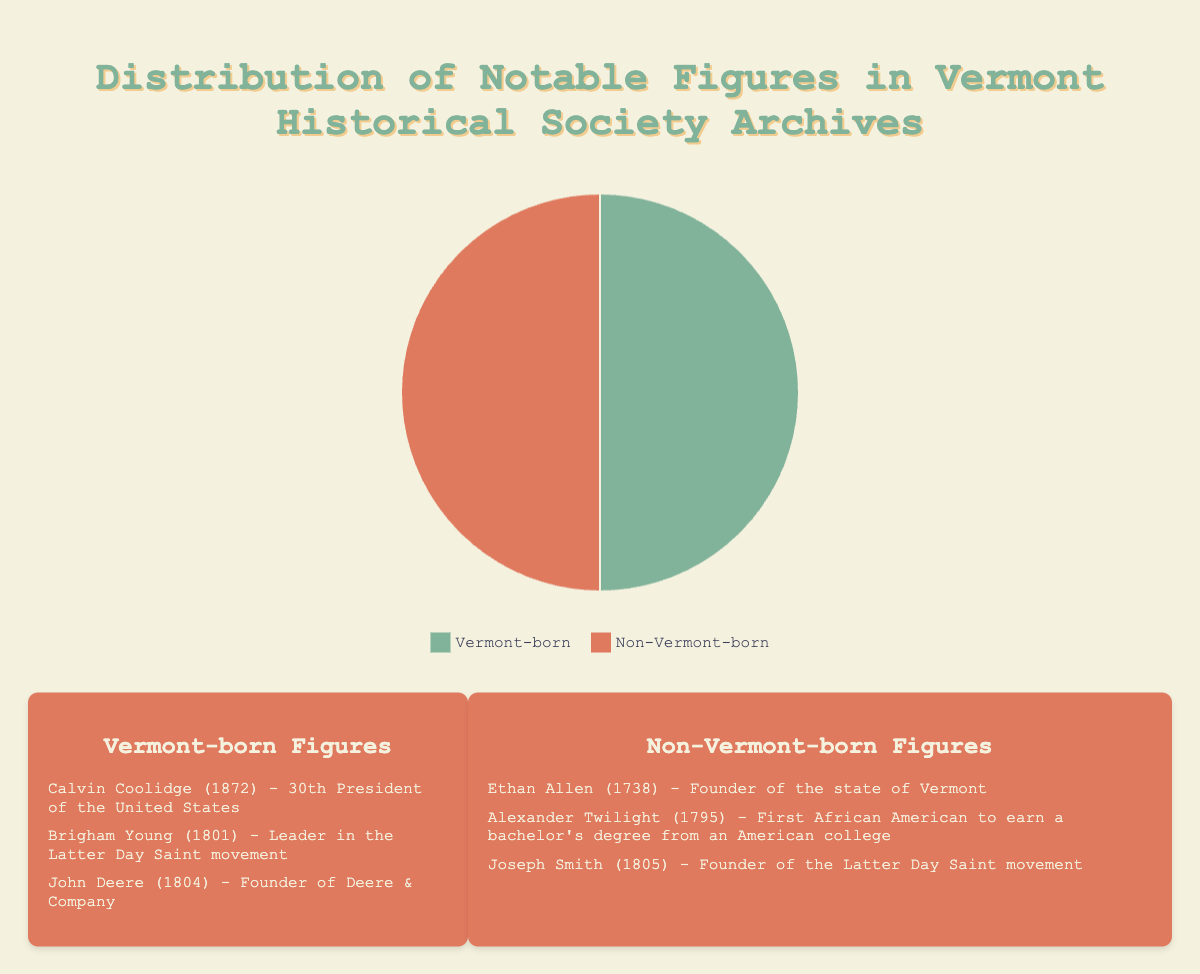What's the proportion of Vermont-born figures in the Vermont Historical Society archives? From the pie chart, we see that the Vermont-born figures make up half of the chart since there are 3 Vermont-born figures out of a total of 6 figures. Therefore, the proportion is 3/6 = 0.5 or 50%.
Answer: 50% Which group has more figures, Vermont-born or non-Vermont-born? Looking at the pie chart, each group occupies an equal portion of the pie chart, indicating that there are the same number of figures in each group.
Answer: Both are equal How many more Vermont-born figures are there compared to non-Vermont-born figures? From the pie chart, we can see that both Vermont-born and non-Vermont-born figures occupy equal portions (3 each). Therefore, there is no difference in their numbers.
Answer: 0 What's the total number of notable figures archived by the Vermont Historical Society? The pie chart shows two groups: Vermont-born (3) and non-Vermont-born (3). Adding them together gives us: 3 + 3 = 6.
Answer: 6 If one more Vermont-born figure were added to the archives, what would be the new proportion of Vermont-born figures? Currently, there are 3 Vermont-born figures out of 6 total figures. If we add one more to Vermont-born, then it becomes 4 Vermont-born figures out of 7 total figures. The new proportion will be 4/7.
Answer: 4/7 Which color in the pie chart represents non-Vermont-born figures? Looking at the legend, the non-Vermont-born figures are associated with the red color.
Answer: Red By what percentage would the Vermont-born figures increase if one Vermont-born figure were added to the archives? Currently, there are 3 Vermont-born figures. Adding one more makes it 4. The percentage increase can be calculated as ((4 - 3) / 3) * 100% = 33.33%.
Answer: 33.33% If two non-Vermont-born figures were removed, what would be the new ratio of Vermont-born to non-Vermont-born figures? Currently, there are 3 of each. Removing 2 from non-Vermont-born leaves 1 non-Vermont-born. The new ratio of Vermont-born (3) to non-Vermont-born (1) figures is 3:1.
Answer: 3:1 What is the difference in percentages between Vermont-born and non-Vermont-born figures? Both Vermont-born and non-Vermont-born figures make up 50% of the total each. Therefore, the difference in percentages is 50% - 50% = 0%.
Answer: 0% 